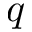<formula> <loc_0><loc_0><loc_500><loc_500>q</formula> 